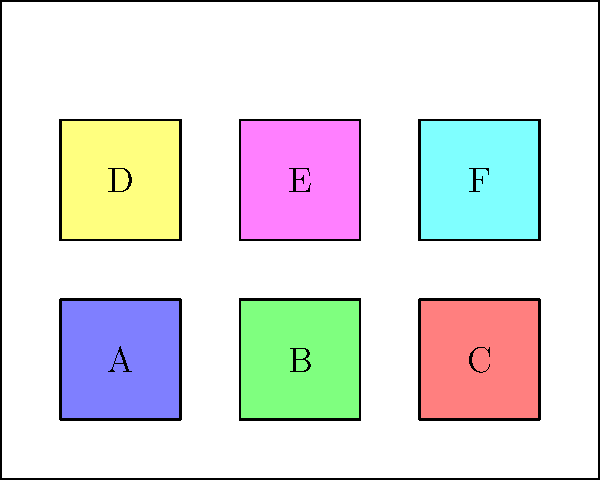You have six meal prep containers of equal size (labeled A to F) that need to be stored on a refrigerator shelf. The shelf can accommodate two rows of three containers each. If you want to maximize the accessibility of the containers based on the frequency of use, with A being used most frequently and F least frequently, what is the optimal arrangement of the containers on the shelf? To maximize accessibility based on frequency of use, we should arrange the containers from most frequently used to least frequently used, starting from the front of the shelf and moving towards the back. This arrangement will minimize the time and effort required to access the most commonly used containers.

Step 1: Identify the order of frequency: A > B > C > D > E > F

Step 2: Arrange the containers in two rows of three, starting from the front:

Front row (from left to right): A, B, C
Back row (from left to right): D, E, F

This arrangement ensures that:
1. Container A, the most frequently used, is in the front left corner for easiest access.
2. Containers B and C, the next most frequently used, are also in the front row.
3. Containers D, E, and F, which are used less frequently, are placed in the back row.

By following this arrangement, you minimize the need to move containers around to access the ones you use most often, thereby maximizing efficiency in your meal prep workflow.
Answer: Front row: A-B-C, Back row: D-E-F 